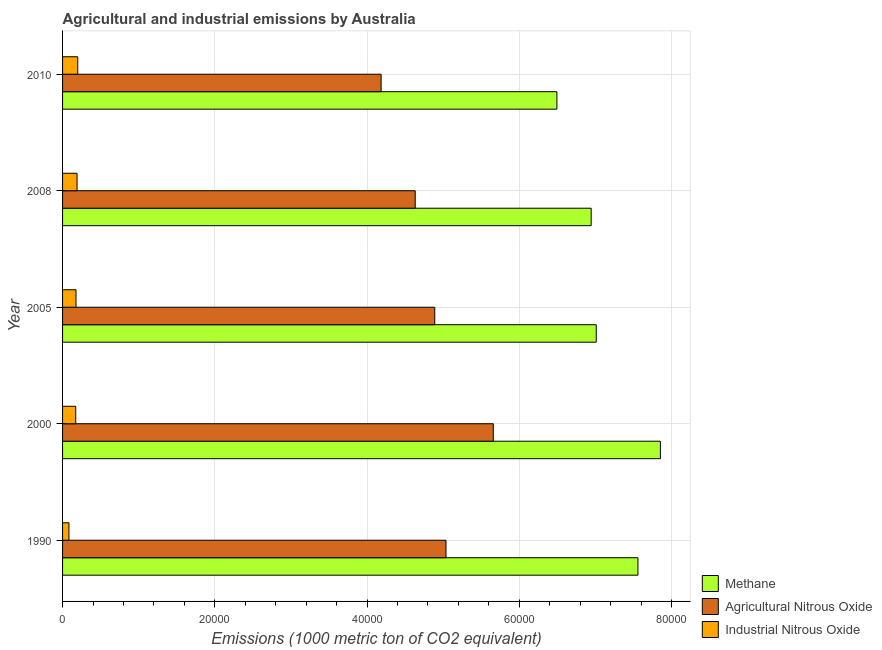Are the number of bars per tick equal to the number of legend labels?
Offer a terse response. Yes. Are the number of bars on each tick of the Y-axis equal?
Ensure brevity in your answer.  Yes. How many bars are there on the 3rd tick from the top?
Your answer should be compact. 3. How many bars are there on the 5th tick from the bottom?
Provide a succinct answer. 3. What is the label of the 3rd group of bars from the top?
Provide a succinct answer. 2005. What is the amount of methane emissions in 2010?
Make the answer very short. 6.50e+04. Across all years, what is the maximum amount of industrial nitrous oxide emissions?
Your answer should be very brief. 1994.8. Across all years, what is the minimum amount of agricultural nitrous oxide emissions?
Offer a terse response. 4.19e+04. What is the total amount of methane emissions in the graph?
Keep it short and to the point. 3.59e+05. What is the difference between the amount of agricultural nitrous oxide emissions in 1990 and that in 2005?
Your answer should be very brief. 1475.2. What is the difference between the amount of methane emissions in 2010 and the amount of agricultural nitrous oxide emissions in 2008?
Keep it short and to the point. 1.86e+04. What is the average amount of industrial nitrous oxide emissions per year?
Your response must be concise. 1646.6. In the year 2010, what is the difference between the amount of industrial nitrous oxide emissions and amount of methane emissions?
Offer a very short reply. -6.30e+04. What is the ratio of the amount of methane emissions in 1990 to that in 2008?
Offer a very short reply. 1.09. Is the amount of agricultural nitrous oxide emissions in 2000 less than that in 2008?
Your answer should be compact. No. Is the difference between the amount of industrial nitrous oxide emissions in 2008 and 2010 greater than the difference between the amount of agricultural nitrous oxide emissions in 2008 and 2010?
Make the answer very short. No. What is the difference between the highest and the second highest amount of industrial nitrous oxide emissions?
Your response must be concise. 91.7. What is the difference between the highest and the lowest amount of agricultural nitrous oxide emissions?
Make the answer very short. 1.47e+04. In how many years, is the amount of agricultural nitrous oxide emissions greater than the average amount of agricultural nitrous oxide emissions taken over all years?
Your response must be concise. 3. Is the sum of the amount of agricultural nitrous oxide emissions in 1990 and 2008 greater than the maximum amount of industrial nitrous oxide emissions across all years?
Keep it short and to the point. Yes. What does the 2nd bar from the top in 2008 represents?
Provide a succinct answer. Agricultural Nitrous Oxide. What does the 1st bar from the bottom in 2010 represents?
Provide a succinct answer. Methane. Are all the bars in the graph horizontal?
Your answer should be very brief. Yes. How many legend labels are there?
Make the answer very short. 3. What is the title of the graph?
Provide a short and direct response. Agricultural and industrial emissions by Australia. What is the label or title of the X-axis?
Keep it short and to the point. Emissions (1000 metric ton of CO2 equivalent). What is the Emissions (1000 metric ton of CO2 equivalent) of Methane in 1990?
Provide a short and direct response. 7.56e+04. What is the Emissions (1000 metric ton of CO2 equivalent) in Agricultural Nitrous Oxide in 1990?
Provide a succinct answer. 5.04e+04. What is the Emissions (1000 metric ton of CO2 equivalent) in Industrial Nitrous Oxide in 1990?
Keep it short and to the point. 839.8. What is the Emissions (1000 metric ton of CO2 equivalent) of Methane in 2000?
Offer a very short reply. 7.85e+04. What is the Emissions (1000 metric ton of CO2 equivalent) in Agricultural Nitrous Oxide in 2000?
Make the answer very short. 5.66e+04. What is the Emissions (1000 metric ton of CO2 equivalent) of Industrial Nitrous Oxide in 2000?
Provide a succinct answer. 1729.8. What is the Emissions (1000 metric ton of CO2 equivalent) of Methane in 2005?
Offer a terse response. 7.01e+04. What is the Emissions (1000 metric ton of CO2 equivalent) of Agricultural Nitrous Oxide in 2005?
Offer a very short reply. 4.89e+04. What is the Emissions (1000 metric ton of CO2 equivalent) of Industrial Nitrous Oxide in 2005?
Your response must be concise. 1765.5. What is the Emissions (1000 metric ton of CO2 equivalent) of Methane in 2008?
Your response must be concise. 6.95e+04. What is the Emissions (1000 metric ton of CO2 equivalent) in Agricultural Nitrous Oxide in 2008?
Your answer should be very brief. 4.63e+04. What is the Emissions (1000 metric ton of CO2 equivalent) of Industrial Nitrous Oxide in 2008?
Provide a short and direct response. 1903.1. What is the Emissions (1000 metric ton of CO2 equivalent) of Methane in 2010?
Offer a very short reply. 6.50e+04. What is the Emissions (1000 metric ton of CO2 equivalent) in Agricultural Nitrous Oxide in 2010?
Offer a very short reply. 4.19e+04. What is the Emissions (1000 metric ton of CO2 equivalent) in Industrial Nitrous Oxide in 2010?
Provide a short and direct response. 1994.8. Across all years, what is the maximum Emissions (1000 metric ton of CO2 equivalent) in Methane?
Offer a terse response. 7.85e+04. Across all years, what is the maximum Emissions (1000 metric ton of CO2 equivalent) in Agricultural Nitrous Oxide?
Give a very brief answer. 5.66e+04. Across all years, what is the maximum Emissions (1000 metric ton of CO2 equivalent) in Industrial Nitrous Oxide?
Give a very brief answer. 1994.8. Across all years, what is the minimum Emissions (1000 metric ton of CO2 equivalent) in Methane?
Your answer should be very brief. 6.50e+04. Across all years, what is the minimum Emissions (1000 metric ton of CO2 equivalent) in Agricultural Nitrous Oxide?
Your response must be concise. 4.19e+04. Across all years, what is the minimum Emissions (1000 metric ton of CO2 equivalent) of Industrial Nitrous Oxide?
Provide a succinct answer. 839.8. What is the total Emissions (1000 metric ton of CO2 equivalent) in Methane in the graph?
Ensure brevity in your answer.  3.59e+05. What is the total Emissions (1000 metric ton of CO2 equivalent) of Agricultural Nitrous Oxide in the graph?
Offer a very short reply. 2.44e+05. What is the total Emissions (1000 metric ton of CO2 equivalent) of Industrial Nitrous Oxide in the graph?
Make the answer very short. 8233. What is the difference between the Emissions (1000 metric ton of CO2 equivalent) of Methane in 1990 and that in 2000?
Keep it short and to the point. -2952.5. What is the difference between the Emissions (1000 metric ton of CO2 equivalent) in Agricultural Nitrous Oxide in 1990 and that in 2000?
Provide a short and direct response. -6212.8. What is the difference between the Emissions (1000 metric ton of CO2 equivalent) in Industrial Nitrous Oxide in 1990 and that in 2000?
Make the answer very short. -890. What is the difference between the Emissions (1000 metric ton of CO2 equivalent) of Methane in 1990 and that in 2005?
Provide a short and direct response. 5478.7. What is the difference between the Emissions (1000 metric ton of CO2 equivalent) of Agricultural Nitrous Oxide in 1990 and that in 2005?
Your response must be concise. 1475.2. What is the difference between the Emissions (1000 metric ton of CO2 equivalent) of Industrial Nitrous Oxide in 1990 and that in 2005?
Your response must be concise. -925.7. What is the difference between the Emissions (1000 metric ton of CO2 equivalent) of Methane in 1990 and that in 2008?
Offer a terse response. 6145.3. What is the difference between the Emissions (1000 metric ton of CO2 equivalent) of Agricultural Nitrous Oxide in 1990 and that in 2008?
Provide a short and direct response. 4045.5. What is the difference between the Emissions (1000 metric ton of CO2 equivalent) of Industrial Nitrous Oxide in 1990 and that in 2008?
Make the answer very short. -1063.3. What is the difference between the Emissions (1000 metric ton of CO2 equivalent) in Methane in 1990 and that in 2010?
Give a very brief answer. 1.06e+04. What is the difference between the Emissions (1000 metric ton of CO2 equivalent) in Agricultural Nitrous Oxide in 1990 and that in 2010?
Provide a short and direct response. 8525.4. What is the difference between the Emissions (1000 metric ton of CO2 equivalent) of Industrial Nitrous Oxide in 1990 and that in 2010?
Offer a very short reply. -1155. What is the difference between the Emissions (1000 metric ton of CO2 equivalent) of Methane in 2000 and that in 2005?
Provide a succinct answer. 8431.2. What is the difference between the Emissions (1000 metric ton of CO2 equivalent) in Agricultural Nitrous Oxide in 2000 and that in 2005?
Keep it short and to the point. 7688. What is the difference between the Emissions (1000 metric ton of CO2 equivalent) of Industrial Nitrous Oxide in 2000 and that in 2005?
Ensure brevity in your answer.  -35.7. What is the difference between the Emissions (1000 metric ton of CO2 equivalent) of Methane in 2000 and that in 2008?
Provide a short and direct response. 9097.8. What is the difference between the Emissions (1000 metric ton of CO2 equivalent) in Agricultural Nitrous Oxide in 2000 and that in 2008?
Give a very brief answer. 1.03e+04. What is the difference between the Emissions (1000 metric ton of CO2 equivalent) in Industrial Nitrous Oxide in 2000 and that in 2008?
Keep it short and to the point. -173.3. What is the difference between the Emissions (1000 metric ton of CO2 equivalent) of Methane in 2000 and that in 2010?
Make the answer very short. 1.36e+04. What is the difference between the Emissions (1000 metric ton of CO2 equivalent) in Agricultural Nitrous Oxide in 2000 and that in 2010?
Provide a short and direct response. 1.47e+04. What is the difference between the Emissions (1000 metric ton of CO2 equivalent) of Industrial Nitrous Oxide in 2000 and that in 2010?
Offer a very short reply. -265. What is the difference between the Emissions (1000 metric ton of CO2 equivalent) in Methane in 2005 and that in 2008?
Your response must be concise. 666.6. What is the difference between the Emissions (1000 metric ton of CO2 equivalent) of Agricultural Nitrous Oxide in 2005 and that in 2008?
Provide a succinct answer. 2570.3. What is the difference between the Emissions (1000 metric ton of CO2 equivalent) in Industrial Nitrous Oxide in 2005 and that in 2008?
Give a very brief answer. -137.6. What is the difference between the Emissions (1000 metric ton of CO2 equivalent) in Methane in 2005 and that in 2010?
Make the answer very short. 5168.4. What is the difference between the Emissions (1000 metric ton of CO2 equivalent) in Agricultural Nitrous Oxide in 2005 and that in 2010?
Give a very brief answer. 7050.2. What is the difference between the Emissions (1000 metric ton of CO2 equivalent) in Industrial Nitrous Oxide in 2005 and that in 2010?
Ensure brevity in your answer.  -229.3. What is the difference between the Emissions (1000 metric ton of CO2 equivalent) in Methane in 2008 and that in 2010?
Ensure brevity in your answer.  4501.8. What is the difference between the Emissions (1000 metric ton of CO2 equivalent) of Agricultural Nitrous Oxide in 2008 and that in 2010?
Ensure brevity in your answer.  4479.9. What is the difference between the Emissions (1000 metric ton of CO2 equivalent) of Industrial Nitrous Oxide in 2008 and that in 2010?
Offer a terse response. -91.7. What is the difference between the Emissions (1000 metric ton of CO2 equivalent) of Methane in 1990 and the Emissions (1000 metric ton of CO2 equivalent) of Agricultural Nitrous Oxide in 2000?
Make the answer very short. 1.90e+04. What is the difference between the Emissions (1000 metric ton of CO2 equivalent) of Methane in 1990 and the Emissions (1000 metric ton of CO2 equivalent) of Industrial Nitrous Oxide in 2000?
Provide a short and direct response. 7.39e+04. What is the difference between the Emissions (1000 metric ton of CO2 equivalent) of Agricultural Nitrous Oxide in 1990 and the Emissions (1000 metric ton of CO2 equivalent) of Industrial Nitrous Oxide in 2000?
Keep it short and to the point. 4.86e+04. What is the difference between the Emissions (1000 metric ton of CO2 equivalent) of Methane in 1990 and the Emissions (1000 metric ton of CO2 equivalent) of Agricultural Nitrous Oxide in 2005?
Give a very brief answer. 2.67e+04. What is the difference between the Emissions (1000 metric ton of CO2 equivalent) in Methane in 1990 and the Emissions (1000 metric ton of CO2 equivalent) in Industrial Nitrous Oxide in 2005?
Ensure brevity in your answer.  7.38e+04. What is the difference between the Emissions (1000 metric ton of CO2 equivalent) of Agricultural Nitrous Oxide in 1990 and the Emissions (1000 metric ton of CO2 equivalent) of Industrial Nitrous Oxide in 2005?
Provide a short and direct response. 4.86e+04. What is the difference between the Emissions (1000 metric ton of CO2 equivalent) in Methane in 1990 and the Emissions (1000 metric ton of CO2 equivalent) in Agricultural Nitrous Oxide in 2008?
Keep it short and to the point. 2.93e+04. What is the difference between the Emissions (1000 metric ton of CO2 equivalent) in Methane in 1990 and the Emissions (1000 metric ton of CO2 equivalent) in Industrial Nitrous Oxide in 2008?
Provide a short and direct response. 7.37e+04. What is the difference between the Emissions (1000 metric ton of CO2 equivalent) in Agricultural Nitrous Oxide in 1990 and the Emissions (1000 metric ton of CO2 equivalent) in Industrial Nitrous Oxide in 2008?
Make the answer very short. 4.85e+04. What is the difference between the Emissions (1000 metric ton of CO2 equivalent) of Methane in 1990 and the Emissions (1000 metric ton of CO2 equivalent) of Agricultural Nitrous Oxide in 2010?
Ensure brevity in your answer.  3.37e+04. What is the difference between the Emissions (1000 metric ton of CO2 equivalent) in Methane in 1990 and the Emissions (1000 metric ton of CO2 equivalent) in Industrial Nitrous Oxide in 2010?
Your answer should be compact. 7.36e+04. What is the difference between the Emissions (1000 metric ton of CO2 equivalent) in Agricultural Nitrous Oxide in 1990 and the Emissions (1000 metric ton of CO2 equivalent) in Industrial Nitrous Oxide in 2010?
Provide a succinct answer. 4.84e+04. What is the difference between the Emissions (1000 metric ton of CO2 equivalent) in Methane in 2000 and the Emissions (1000 metric ton of CO2 equivalent) in Agricultural Nitrous Oxide in 2005?
Your answer should be compact. 2.96e+04. What is the difference between the Emissions (1000 metric ton of CO2 equivalent) in Methane in 2000 and the Emissions (1000 metric ton of CO2 equivalent) in Industrial Nitrous Oxide in 2005?
Your response must be concise. 7.68e+04. What is the difference between the Emissions (1000 metric ton of CO2 equivalent) of Agricultural Nitrous Oxide in 2000 and the Emissions (1000 metric ton of CO2 equivalent) of Industrial Nitrous Oxide in 2005?
Provide a succinct answer. 5.48e+04. What is the difference between the Emissions (1000 metric ton of CO2 equivalent) in Methane in 2000 and the Emissions (1000 metric ton of CO2 equivalent) in Agricultural Nitrous Oxide in 2008?
Provide a short and direct response. 3.22e+04. What is the difference between the Emissions (1000 metric ton of CO2 equivalent) in Methane in 2000 and the Emissions (1000 metric ton of CO2 equivalent) in Industrial Nitrous Oxide in 2008?
Provide a short and direct response. 7.66e+04. What is the difference between the Emissions (1000 metric ton of CO2 equivalent) of Agricultural Nitrous Oxide in 2000 and the Emissions (1000 metric ton of CO2 equivalent) of Industrial Nitrous Oxide in 2008?
Provide a succinct answer. 5.47e+04. What is the difference between the Emissions (1000 metric ton of CO2 equivalent) in Methane in 2000 and the Emissions (1000 metric ton of CO2 equivalent) in Agricultural Nitrous Oxide in 2010?
Ensure brevity in your answer.  3.67e+04. What is the difference between the Emissions (1000 metric ton of CO2 equivalent) of Methane in 2000 and the Emissions (1000 metric ton of CO2 equivalent) of Industrial Nitrous Oxide in 2010?
Your answer should be compact. 7.66e+04. What is the difference between the Emissions (1000 metric ton of CO2 equivalent) in Agricultural Nitrous Oxide in 2000 and the Emissions (1000 metric ton of CO2 equivalent) in Industrial Nitrous Oxide in 2010?
Provide a succinct answer. 5.46e+04. What is the difference between the Emissions (1000 metric ton of CO2 equivalent) of Methane in 2005 and the Emissions (1000 metric ton of CO2 equivalent) of Agricultural Nitrous Oxide in 2008?
Provide a short and direct response. 2.38e+04. What is the difference between the Emissions (1000 metric ton of CO2 equivalent) in Methane in 2005 and the Emissions (1000 metric ton of CO2 equivalent) in Industrial Nitrous Oxide in 2008?
Provide a succinct answer. 6.82e+04. What is the difference between the Emissions (1000 metric ton of CO2 equivalent) of Agricultural Nitrous Oxide in 2005 and the Emissions (1000 metric ton of CO2 equivalent) of Industrial Nitrous Oxide in 2008?
Make the answer very short. 4.70e+04. What is the difference between the Emissions (1000 metric ton of CO2 equivalent) in Methane in 2005 and the Emissions (1000 metric ton of CO2 equivalent) in Agricultural Nitrous Oxide in 2010?
Provide a short and direct response. 2.83e+04. What is the difference between the Emissions (1000 metric ton of CO2 equivalent) of Methane in 2005 and the Emissions (1000 metric ton of CO2 equivalent) of Industrial Nitrous Oxide in 2010?
Give a very brief answer. 6.81e+04. What is the difference between the Emissions (1000 metric ton of CO2 equivalent) of Agricultural Nitrous Oxide in 2005 and the Emissions (1000 metric ton of CO2 equivalent) of Industrial Nitrous Oxide in 2010?
Your response must be concise. 4.69e+04. What is the difference between the Emissions (1000 metric ton of CO2 equivalent) in Methane in 2008 and the Emissions (1000 metric ton of CO2 equivalent) in Agricultural Nitrous Oxide in 2010?
Provide a short and direct response. 2.76e+04. What is the difference between the Emissions (1000 metric ton of CO2 equivalent) in Methane in 2008 and the Emissions (1000 metric ton of CO2 equivalent) in Industrial Nitrous Oxide in 2010?
Offer a very short reply. 6.75e+04. What is the difference between the Emissions (1000 metric ton of CO2 equivalent) of Agricultural Nitrous Oxide in 2008 and the Emissions (1000 metric ton of CO2 equivalent) of Industrial Nitrous Oxide in 2010?
Keep it short and to the point. 4.43e+04. What is the average Emissions (1000 metric ton of CO2 equivalent) in Methane per year?
Keep it short and to the point. 7.17e+04. What is the average Emissions (1000 metric ton of CO2 equivalent) in Agricultural Nitrous Oxide per year?
Your answer should be very brief. 4.88e+04. What is the average Emissions (1000 metric ton of CO2 equivalent) in Industrial Nitrous Oxide per year?
Keep it short and to the point. 1646.6. In the year 1990, what is the difference between the Emissions (1000 metric ton of CO2 equivalent) of Methane and Emissions (1000 metric ton of CO2 equivalent) of Agricultural Nitrous Oxide?
Keep it short and to the point. 2.52e+04. In the year 1990, what is the difference between the Emissions (1000 metric ton of CO2 equivalent) of Methane and Emissions (1000 metric ton of CO2 equivalent) of Industrial Nitrous Oxide?
Provide a succinct answer. 7.48e+04. In the year 1990, what is the difference between the Emissions (1000 metric ton of CO2 equivalent) in Agricultural Nitrous Oxide and Emissions (1000 metric ton of CO2 equivalent) in Industrial Nitrous Oxide?
Provide a short and direct response. 4.95e+04. In the year 2000, what is the difference between the Emissions (1000 metric ton of CO2 equivalent) of Methane and Emissions (1000 metric ton of CO2 equivalent) of Agricultural Nitrous Oxide?
Give a very brief answer. 2.20e+04. In the year 2000, what is the difference between the Emissions (1000 metric ton of CO2 equivalent) of Methane and Emissions (1000 metric ton of CO2 equivalent) of Industrial Nitrous Oxide?
Give a very brief answer. 7.68e+04. In the year 2000, what is the difference between the Emissions (1000 metric ton of CO2 equivalent) of Agricultural Nitrous Oxide and Emissions (1000 metric ton of CO2 equivalent) of Industrial Nitrous Oxide?
Make the answer very short. 5.49e+04. In the year 2005, what is the difference between the Emissions (1000 metric ton of CO2 equivalent) in Methane and Emissions (1000 metric ton of CO2 equivalent) in Agricultural Nitrous Oxide?
Ensure brevity in your answer.  2.12e+04. In the year 2005, what is the difference between the Emissions (1000 metric ton of CO2 equivalent) in Methane and Emissions (1000 metric ton of CO2 equivalent) in Industrial Nitrous Oxide?
Your answer should be very brief. 6.84e+04. In the year 2005, what is the difference between the Emissions (1000 metric ton of CO2 equivalent) in Agricultural Nitrous Oxide and Emissions (1000 metric ton of CO2 equivalent) in Industrial Nitrous Oxide?
Your response must be concise. 4.71e+04. In the year 2008, what is the difference between the Emissions (1000 metric ton of CO2 equivalent) in Methane and Emissions (1000 metric ton of CO2 equivalent) in Agricultural Nitrous Oxide?
Your answer should be very brief. 2.31e+04. In the year 2008, what is the difference between the Emissions (1000 metric ton of CO2 equivalent) of Methane and Emissions (1000 metric ton of CO2 equivalent) of Industrial Nitrous Oxide?
Keep it short and to the point. 6.75e+04. In the year 2008, what is the difference between the Emissions (1000 metric ton of CO2 equivalent) of Agricultural Nitrous Oxide and Emissions (1000 metric ton of CO2 equivalent) of Industrial Nitrous Oxide?
Provide a succinct answer. 4.44e+04. In the year 2010, what is the difference between the Emissions (1000 metric ton of CO2 equivalent) in Methane and Emissions (1000 metric ton of CO2 equivalent) in Agricultural Nitrous Oxide?
Offer a terse response. 2.31e+04. In the year 2010, what is the difference between the Emissions (1000 metric ton of CO2 equivalent) of Methane and Emissions (1000 metric ton of CO2 equivalent) of Industrial Nitrous Oxide?
Keep it short and to the point. 6.30e+04. In the year 2010, what is the difference between the Emissions (1000 metric ton of CO2 equivalent) in Agricultural Nitrous Oxide and Emissions (1000 metric ton of CO2 equivalent) in Industrial Nitrous Oxide?
Make the answer very short. 3.99e+04. What is the ratio of the Emissions (1000 metric ton of CO2 equivalent) in Methane in 1990 to that in 2000?
Your response must be concise. 0.96. What is the ratio of the Emissions (1000 metric ton of CO2 equivalent) of Agricultural Nitrous Oxide in 1990 to that in 2000?
Offer a very short reply. 0.89. What is the ratio of the Emissions (1000 metric ton of CO2 equivalent) of Industrial Nitrous Oxide in 1990 to that in 2000?
Ensure brevity in your answer.  0.49. What is the ratio of the Emissions (1000 metric ton of CO2 equivalent) in Methane in 1990 to that in 2005?
Keep it short and to the point. 1.08. What is the ratio of the Emissions (1000 metric ton of CO2 equivalent) of Agricultural Nitrous Oxide in 1990 to that in 2005?
Keep it short and to the point. 1.03. What is the ratio of the Emissions (1000 metric ton of CO2 equivalent) in Industrial Nitrous Oxide in 1990 to that in 2005?
Your answer should be very brief. 0.48. What is the ratio of the Emissions (1000 metric ton of CO2 equivalent) in Methane in 1990 to that in 2008?
Provide a short and direct response. 1.09. What is the ratio of the Emissions (1000 metric ton of CO2 equivalent) of Agricultural Nitrous Oxide in 1990 to that in 2008?
Your answer should be compact. 1.09. What is the ratio of the Emissions (1000 metric ton of CO2 equivalent) of Industrial Nitrous Oxide in 1990 to that in 2008?
Offer a very short reply. 0.44. What is the ratio of the Emissions (1000 metric ton of CO2 equivalent) of Methane in 1990 to that in 2010?
Provide a short and direct response. 1.16. What is the ratio of the Emissions (1000 metric ton of CO2 equivalent) of Agricultural Nitrous Oxide in 1990 to that in 2010?
Your answer should be very brief. 1.2. What is the ratio of the Emissions (1000 metric ton of CO2 equivalent) in Industrial Nitrous Oxide in 1990 to that in 2010?
Keep it short and to the point. 0.42. What is the ratio of the Emissions (1000 metric ton of CO2 equivalent) of Methane in 2000 to that in 2005?
Your answer should be very brief. 1.12. What is the ratio of the Emissions (1000 metric ton of CO2 equivalent) in Agricultural Nitrous Oxide in 2000 to that in 2005?
Give a very brief answer. 1.16. What is the ratio of the Emissions (1000 metric ton of CO2 equivalent) in Industrial Nitrous Oxide in 2000 to that in 2005?
Offer a very short reply. 0.98. What is the ratio of the Emissions (1000 metric ton of CO2 equivalent) in Methane in 2000 to that in 2008?
Make the answer very short. 1.13. What is the ratio of the Emissions (1000 metric ton of CO2 equivalent) of Agricultural Nitrous Oxide in 2000 to that in 2008?
Provide a short and direct response. 1.22. What is the ratio of the Emissions (1000 metric ton of CO2 equivalent) of Industrial Nitrous Oxide in 2000 to that in 2008?
Make the answer very short. 0.91. What is the ratio of the Emissions (1000 metric ton of CO2 equivalent) of Methane in 2000 to that in 2010?
Your answer should be compact. 1.21. What is the ratio of the Emissions (1000 metric ton of CO2 equivalent) of Agricultural Nitrous Oxide in 2000 to that in 2010?
Ensure brevity in your answer.  1.35. What is the ratio of the Emissions (1000 metric ton of CO2 equivalent) of Industrial Nitrous Oxide in 2000 to that in 2010?
Your answer should be very brief. 0.87. What is the ratio of the Emissions (1000 metric ton of CO2 equivalent) in Methane in 2005 to that in 2008?
Make the answer very short. 1.01. What is the ratio of the Emissions (1000 metric ton of CO2 equivalent) in Agricultural Nitrous Oxide in 2005 to that in 2008?
Your answer should be very brief. 1.06. What is the ratio of the Emissions (1000 metric ton of CO2 equivalent) of Industrial Nitrous Oxide in 2005 to that in 2008?
Offer a terse response. 0.93. What is the ratio of the Emissions (1000 metric ton of CO2 equivalent) of Methane in 2005 to that in 2010?
Make the answer very short. 1.08. What is the ratio of the Emissions (1000 metric ton of CO2 equivalent) in Agricultural Nitrous Oxide in 2005 to that in 2010?
Ensure brevity in your answer.  1.17. What is the ratio of the Emissions (1000 metric ton of CO2 equivalent) of Industrial Nitrous Oxide in 2005 to that in 2010?
Ensure brevity in your answer.  0.89. What is the ratio of the Emissions (1000 metric ton of CO2 equivalent) in Methane in 2008 to that in 2010?
Keep it short and to the point. 1.07. What is the ratio of the Emissions (1000 metric ton of CO2 equivalent) in Agricultural Nitrous Oxide in 2008 to that in 2010?
Keep it short and to the point. 1.11. What is the ratio of the Emissions (1000 metric ton of CO2 equivalent) of Industrial Nitrous Oxide in 2008 to that in 2010?
Your response must be concise. 0.95. What is the difference between the highest and the second highest Emissions (1000 metric ton of CO2 equivalent) in Methane?
Provide a short and direct response. 2952.5. What is the difference between the highest and the second highest Emissions (1000 metric ton of CO2 equivalent) of Agricultural Nitrous Oxide?
Give a very brief answer. 6212.8. What is the difference between the highest and the second highest Emissions (1000 metric ton of CO2 equivalent) in Industrial Nitrous Oxide?
Your answer should be very brief. 91.7. What is the difference between the highest and the lowest Emissions (1000 metric ton of CO2 equivalent) in Methane?
Ensure brevity in your answer.  1.36e+04. What is the difference between the highest and the lowest Emissions (1000 metric ton of CO2 equivalent) of Agricultural Nitrous Oxide?
Your response must be concise. 1.47e+04. What is the difference between the highest and the lowest Emissions (1000 metric ton of CO2 equivalent) in Industrial Nitrous Oxide?
Ensure brevity in your answer.  1155. 